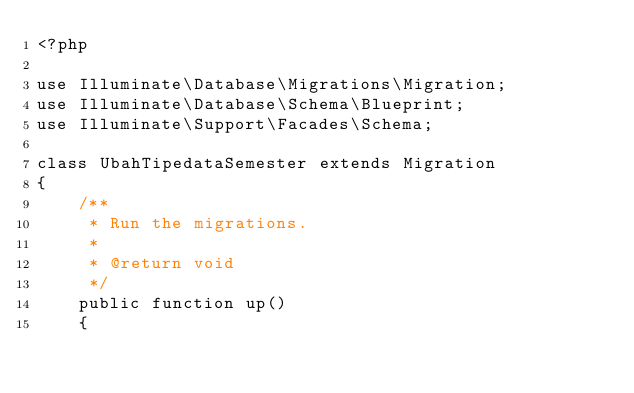<code> <loc_0><loc_0><loc_500><loc_500><_PHP_><?php

use Illuminate\Database\Migrations\Migration;
use Illuminate\Database\Schema\Blueprint;
use Illuminate\Support\Facades\Schema;

class UbahTipedataSemester extends Migration
{
    /**
     * Run the migrations.
     *
     * @return void
     */
    public function up()
    {</code> 